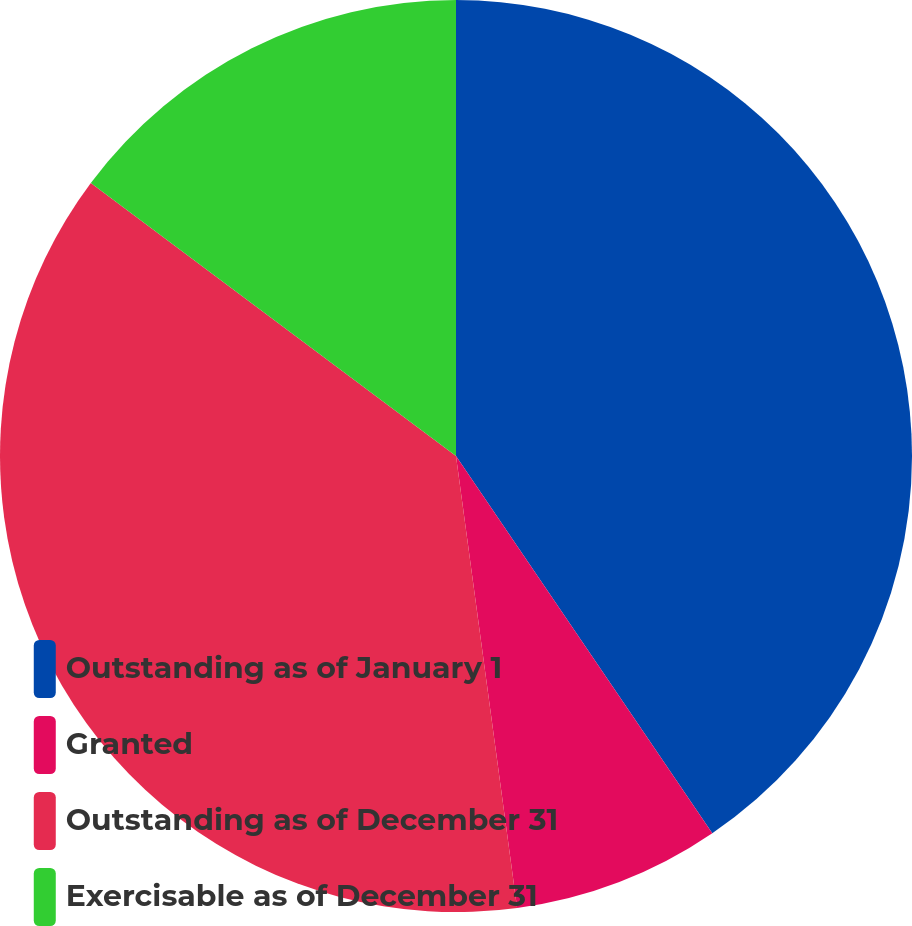<chart> <loc_0><loc_0><loc_500><loc_500><pie_chart><fcel>Outstanding as of January 1<fcel>Granted<fcel>Outstanding as of December 31<fcel>Exercisable as of December 31<nl><fcel>40.5%<fcel>7.36%<fcel>37.36%<fcel>14.78%<nl></chart> 